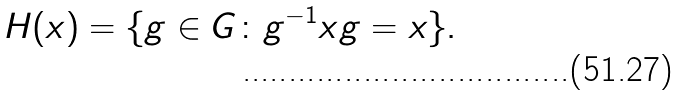<formula> <loc_0><loc_0><loc_500><loc_500>H ( x ) = \{ g \in G \colon g ^ { - 1 } x g = x \} .</formula> 